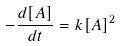Convert formula to latex. <formula><loc_0><loc_0><loc_500><loc_500>- \frac { d [ A ] } { d t } = k [ A ] ^ { 2 }</formula> 